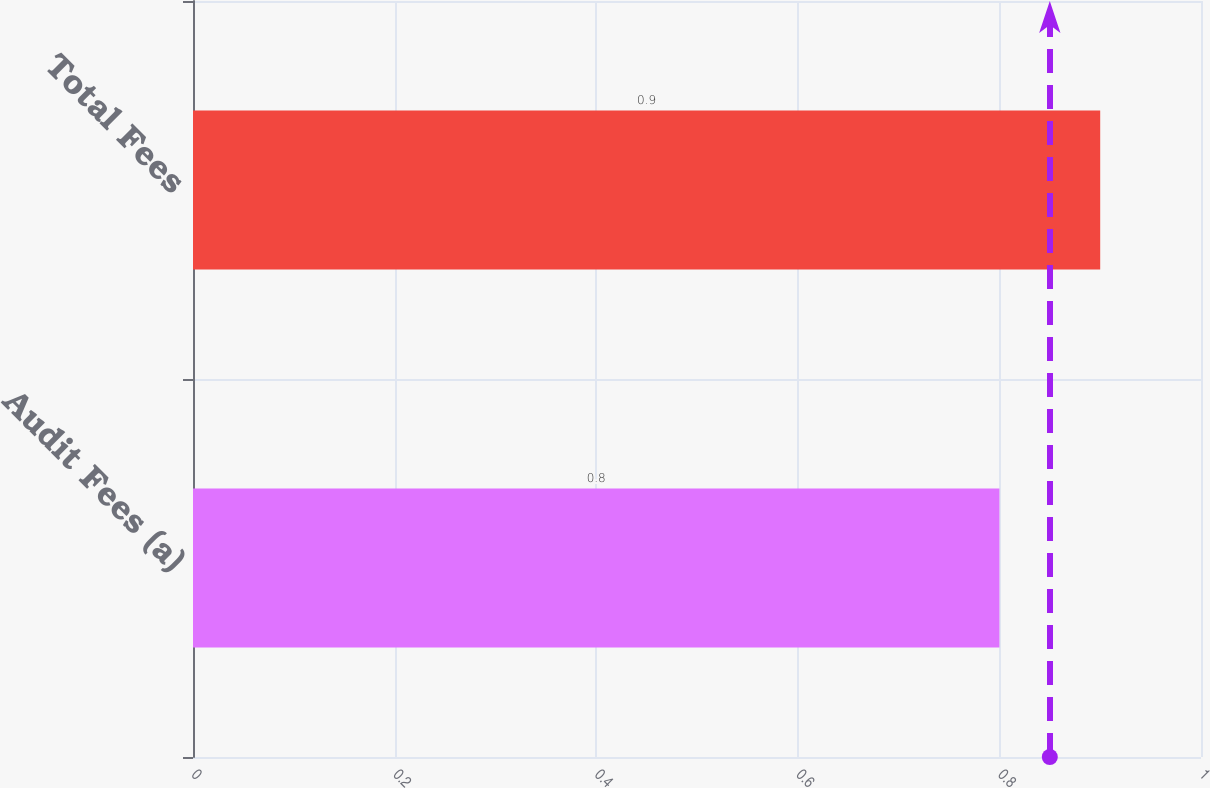Convert chart to OTSL. <chart><loc_0><loc_0><loc_500><loc_500><bar_chart><fcel>Audit Fees (a)<fcel>Total Fees<nl><fcel>0.8<fcel>0.9<nl></chart> 